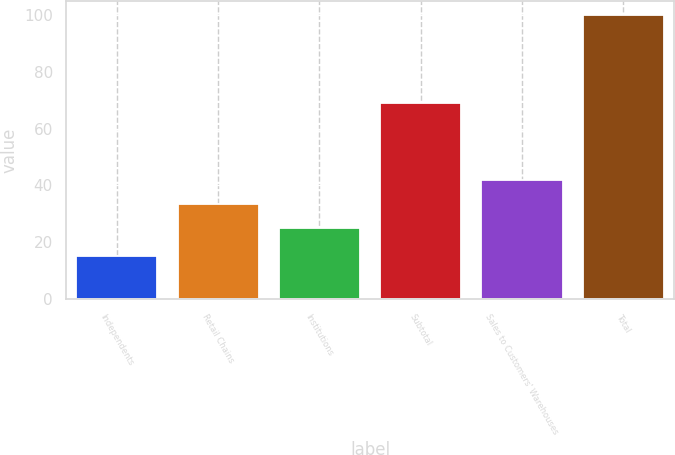Convert chart. <chart><loc_0><loc_0><loc_500><loc_500><bar_chart><fcel>Independents<fcel>Retail Chains<fcel>Institutions<fcel>Subtotal<fcel>Sales to Customers' Warehouses<fcel>Total<nl><fcel>15<fcel>33.5<fcel>25<fcel>69<fcel>42<fcel>100<nl></chart> 